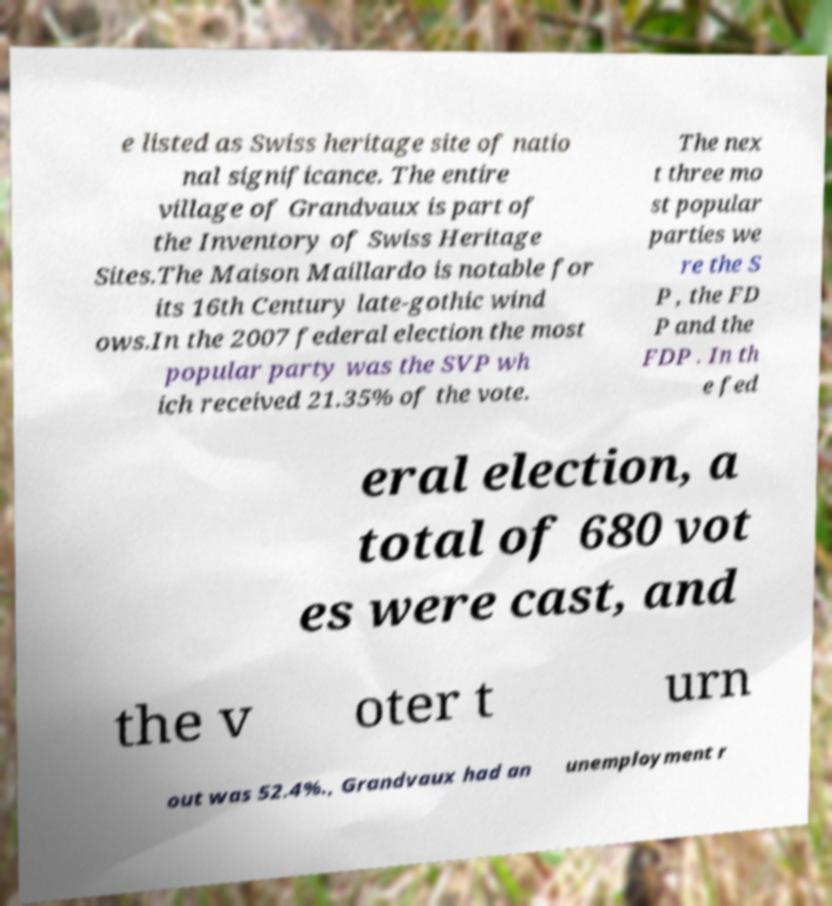Please identify and transcribe the text found in this image. e listed as Swiss heritage site of natio nal significance. The entire village of Grandvaux is part of the Inventory of Swiss Heritage Sites.The Maison Maillardo is notable for its 16th Century late-gothic wind ows.In the 2007 federal election the most popular party was the SVP wh ich received 21.35% of the vote. The nex t three mo st popular parties we re the S P , the FD P and the FDP . In th e fed eral election, a total of 680 vot es were cast, and the v oter t urn out was 52.4%., Grandvaux had an unemployment r 